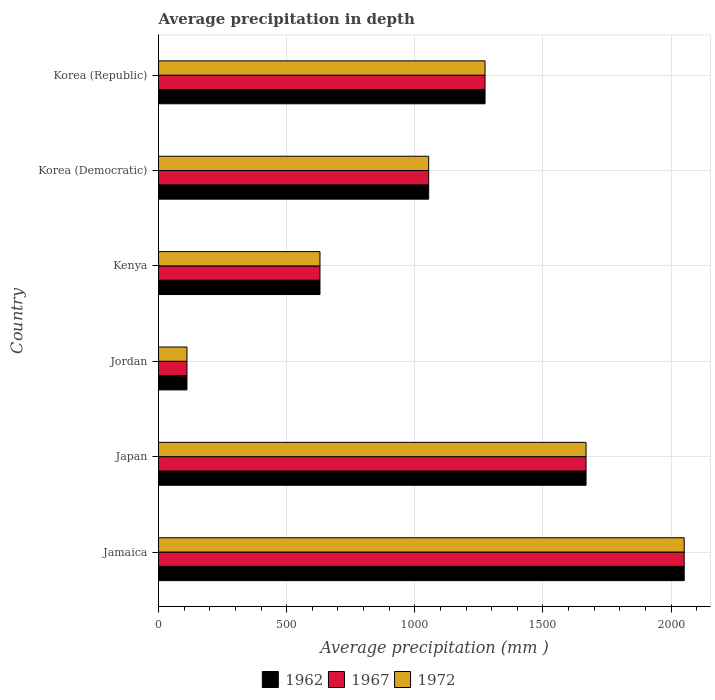How many different coloured bars are there?
Your answer should be very brief. 3. How many groups of bars are there?
Offer a very short reply. 6. How many bars are there on the 3rd tick from the top?
Make the answer very short. 3. What is the average precipitation in 1972 in Kenya?
Your answer should be compact. 630. Across all countries, what is the maximum average precipitation in 1967?
Provide a short and direct response. 2051. Across all countries, what is the minimum average precipitation in 1972?
Provide a short and direct response. 111. In which country was the average precipitation in 1962 maximum?
Provide a succinct answer. Jamaica. In which country was the average precipitation in 1962 minimum?
Your answer should be compact. Jordan. What is the total average precipitation in 1967 in the graph?
Ensure brevity in your answer.  6788. What is the difference between the average precipitation in 1967 in Jordan and that in Kenya?
Your answer should be compact. -519. What is the difference between the average precipitation in 1972 in Japan and the average precipitation in 1967 in Korea (Republic)?
Offer a very short reply. 394. What is the average average precipitation in 1962 per country?
Offer a terse response. 1131.33. What is the difference between the average precipitation in 1972 and average precipitation in 1967 in Kenya?
Your answer should be very brief. 0. What is the ratio of the average precipitation in 1972 in Japan to that in Kenya?
Make the answer very short. 2.65. Is the average precipitation in 1967 in Jamaica less than that in Jordan?
Your answer should be very brief. No. What is the difference between the highest and the second highest average precipitation in 1967?
Your answer should be very brief. 383. What is the difference between the highest and the lowest average precipitation in 1972?
Your answer should be compact. 1940. In how many countries, is the average precipitation in 1962 greater than the average average precipitation in 1962 taken over all countries?
Keep it short and to the point. 3. What does the 3rd bar from the bottom in Korea (Democratic) represents?
Your answer should be very brief. 1972. How many bars are there?
Make the answer very short. 18. What is the difference between two consecutive major ticks on the X-axis?
Keep it short and to the point. 500. Does the graph contain any zero values?
Offer a very short reply. No. How many legend labels are there?
Keep it short and to the point. 3. What is the title of the graph?
Your response must be concise. Average precipitation in depth. What is the label or title of the X-axis?
Give a very brief answer. Average precipitation (mm ). What is the Average precipitation (mm ) in 1962 in Jamaica?
Give a very brief answer. 2051. What is the Average precipitation (mm ) of 1967 in Jamaica?
Give a very brief answer. 2051. What is the Average precipitation (mm ) of 1972 in Jamaica?
Make the answer very short. 2051. What is the Average precipitation (mm ) in 1962 in Japan?
Your response must be concise. 1668. What is the Average precipitation (mm ) of 1967 in Japan?
Ensure brevity in your answer.  1668. What is the Average precipitation (mm ) in 1972 in Japan?
Keep it short and to the point. 1668. What is the Average precipitation (mm ) of 1962 in Jordan?
Your answer should be very brief. 111. What is the Average precipitation (mm ) of 1967 in Jordan?
Make the answer very short. 111. What is the Average precipitation (mm ) of 1972 in Jordan?
Offer a very short reply. 111. What is the Average precipitation (mm ) of 1962 in Kenya?
Make the answer very short. 630. What is the Average precipitation (mm ) of 1967 in Kenya?
Your answer should be compact. 630. What is the Average precipitation (mm ) of 1972 in Kenya?
Ensure brevity in your answer.  630. What is the Average precipitation (mm ) of 1962 in Korea (Democratic)?
Ensure brevity in your answer.  1054. What is the Average precipitation (mm ) of 1967 in Korea (Democratic)?
Give a very brief answer. 1054. What is the Average precipitation (mm ) of 1972 in Korea (Democratic)?
Make the answer very short. 1054. What is the Average precipitation (mm ) in 1962 in Korea (Republic)?
Your answer should be compact. 1274. What is the Average precipitation (mm ) of 1967 in Korea (Republic)?
Offer a very short reply. 1274. What is the Average precipitation (mm ) in 1972 in Korea (Republic)?
Make the answer very short. 1274. Across all countries, what is the maximum Average precipitation (mm ) in 1962?
Ensure brevity in your answer.  2051. Across all countries, what is the maximum Average precipitation (mm ) in 1967?
Ensure brevity in your answer.  2051. Across all countries, what is the maximum Average precipitation (mm ) in 1972?
Offer a very short reply. 2051. Across all countries, what is the minimum Average precipitation (mm ) of 1962?
Offer a terse response. 111. Across all countries, what is the minimum Average precipitation (mm ) in 1967?
Your answer should be compact. 111. Across all countries, what is the minimum Average precipitation (mm ) in 1972?
Offer a terse response. 111. What is the total Average precipitation (mm ) in 1962 in the graph?
Ensure brevity in your answer.  6788. What is the total Average precipitation (mm ) in 1967 in the graph?
Make the answer very short. 6788. What is the total Average precipitation (mm ) of 1972 in the graph?
Offer a terse response. 6788. What is the difference between the Average precipitation (mm ) in 1962 in Jamaica and that in Japan?
Offer a terse response. 383. What is the difference between the Average precipitation (mm ) in 1967 in Jamaica and that in Japan?
Provide a succinct answer. 383. What is the difference between the Average precipitation (mm ) of 1972 in Jamaica and that in Japan?
Make the answer very short. 383. What is the difference between the Average precipitation (mm ) of 1962 in Jamaica and that in Jordan?
Offer a terse response. 1940. What is the difference between the Average precipitation (mm ) of 1967 in Jamaica and that in Jordan?
Offer a terse response. 1940. What is the difference between the Average precipitation (mm ) of 1972 in Jamaica and that in Jordan?
Keep it short and to the point. 1940. What is the difference between the Average precipitation (mm ) in 1962 in Jamaica and that in Kenya?
Your answer should be compact. 1421. What is the difference between the Average precipitation (mm ) of 1967 in Jamaica and that in Kenya?
Provide a short and direct response. 1421. What is the difference between the Average precipitation (mm ) in 1972 in Jamaica and that in Kenya?
Your answer should be compact. 1421. What is the difference between the Average precipitation (mm ) in 1962 in Jamaica and that in Korea (Democratic)?
Your response must be concise. 997. What is the difference between the Average precipitation (mm ) in 1967 in Jamaica and that in Korea (Democratic)?
Keep it short and to the point. 997. What is the difference between the Average precipitation (mm ) of 1972 in Jamaica and that in Korea (Democratic)?
Your answer should be compact. 997. What is the difference between the Average precipitation (mm ) of 1962 in Jamaica and that in Korea (Republic)?
Provide a succinct answer. 777. What is the difference between the Average precipitation (mm ) in 1967 in Jamaica and that in Korea (Republic)?
Your answer should be compact. 777. What is the difference between the Average precipitation (mm ) in 1972 in Jamaica and that in Korea (Republic)?
Ensure brevity in your answer.  777. What is the difference between the Average precipitation (mm ) of 1962 in Japan and that in Jordan?
Offer a terse response. 1557. What is the difference between the Average precipitation (mm ) of 1967 in Japan and that in Jordan?
Provide a short and direct response. 1557. What is the difference between the Average precipitation (mm ) in 1972 in Japan and that in Jordan?
Your answer should be compact. 1557. What is the difference between the Average precipitation (mm ) in 1962 in Japan and that in Kenya?
Your response must be concise. 1038. What is the difference between the Average precipitation (mm ) of 1967 in Japan and that in Kenya?
Provide a succinct answer. 1038. What is the difference between the Average precipitation (mm ) in 1972 in Japan and that in Kenya?
Provide a succinct answer. 1038. What is the difference between the Average precipitation (mm ) in 1962 in Japan and that in Korea (Democratic)?
Ensure brevity in your answer.  614. What is the difference between the Average precipitation (mm ) in 1967 in Japan and that in Korea (Democratic)?
Keep it short and to the point. 614. What is the difference between the Average precipitation (mm ) of 1972 in Japan and that in Korea (Democratic)?
Your answer should be very brief. 614. What is the difference between the Average precipitation (mm ) of 1962 in Japan and that in Korea (Republic)?
Your answer should be compact. 394. What is the difference between the Average precipitation (mm ) in 1967 in Japan and that in Korea (Republic)?
Keep it short and to the point. 394. What is the difference between the Average precipitation (mm ) in 1972 in Japan and that in Korea (Republic)?
Offer a terse response. 394. What is the difference between the Average precipitation (mm ) of 1962 in Jordan and that in Kenya?
Provide a succinct answer. -519. What is the difference between the Average precipitation (mm ) of 1967 in Jordan and that in Kenya?
Your answer should be compact. -519. What is the difference between the Average precipitation (mm ) in 1972 in Jordan and that in Kenya?
Make the answer very short. -519. What is the difference between the Average precipitation (mm ) of 1962 in Jordan and that in Korea (Democratic)?
Keep it short and to the point. -943. What is the difference between the Average precipitation (mm ) of 1967 in Jordan and that in Korea (Democratic)?
Your response must be concise. -943. What is the difference between the Average precipitation (mm ) in 1972 in Jordan and that in Korea (Democratic)?
Keep it short and to the point. -943. What is the difference between the Average precipitation (mm ) of 1962 in Jordan and that in Korea (Republic)?
Provide a succinct answer. -1163. What is the difference between the Average precipitation (mm ) in 1967 in Jordan and that in Korea (Republic)?
Offer a terse response. -1163. What is the difference between the Average precipitation (mm ) in 1972 in Jordan and that in Korea (Republic)?
Make the answer very short. -1163. What is the difference between the Average precipitation (mm ) of 1962 in Kenya and that in Korea (Democratic)?
Your answer should be very brief. -424. What is the difference between the Average precipitation (mm ) in 1967 in Kenya and that in Korea (Democratic)?
Make the answer very short. -424. What is the difference between the Average precipitation (mm ) in 1972 in Kenya and that in Korea (Democratic)?
Keep it short and to the point. -424. What is the difference between the Average precipitation (mm ) of 1962 in Kenya and that in Korea (Republic)?
Offer a very short reply. -644. What is the difference between the Average precipitation (mm ) of 1967 in Kenya and that in Korea (Republic)?
Ensure brevity in your answer.  -644. What is the difference between the Average precipitation (mm ) of 1972 in Kenya and that in Korea (Republic)?
Provide a short and direct response. -644. What is the difference between the Average precipitation (mm ) in 1962 in Korea (Democratic) and that in Korea (Republic)?
Keep it short and to the point. -220. What is the difference between the Average precipitation (mm ) in 1967 in Korea (Democratic) and that in Korea (Republic)?
Offer a terse response. -220. What is the difference between the Average precipitation (mm ) in 1972 in Korea (Democratic) and that in Korea (Republic)?
Ensure brevity in your answer.  -220. What is the difference between the Average precipitation (mm ) of 1962 in Jamaica and the Average precipitation (mm ) of 1967 in Japan?
Provide a short and direct response. 383. What is the difference between the Average precipitation (mm ) of 1962 in Jamaica and the Average precipitation (mm ) of 1972 in Japan?
Offer a very short reply. 383. What is the difference between the Average precipitation (mm ) in 1967 in Jamaica and the Average precipitation (mm ) in 1972 in Japan?
Your answer should be compact. 383. What is the difference between the Average precipitation (mm ) of 1962 in Jamaica and the Average precipitation (mm ) of 1967 in Jordan?
Ensure brevity in your answer.  1940. What is the difference between the Average precipitation (mm ) of 1962 in Jamaica and the Average precipitation (mm ) of 1972 in Jordan?
Ensure brevity in your answer.  1940. What is the difference between the Average precipitation (mm ) in 1967 in Jamaica and the Average precipitation (mm ) in 1972 in Jordan?
Your response must be concise. 1940. What is the difference between the Average precipitation (mm ) in 1962 in Jamaica and the Average precipitation (mm ) in 1967 in Kenya?
Provide a succinct answer. 1421. What is the difference between the Average precipitation (mm ) in 1962 in Jamaica and the Average precipitation (mm ) in 1972 in Kenya?
Provide a succinct answer. 1421. What is the difference between the Average precipitation (mm ) of 1967 in Jamaica and the Average precipitation (mm ) of 1972 in Kenya?
Offer a very short reply. 1421. What is the difference between the Average precipitation (mm ) in 1962 in Jamaica and the Average precipitation (mm ) in 1967 in Korea (Democratic)?
Provide a succinct answer. 997. What is the difference between the Average precipitation (mm ) in 1962 in Jamaica and the Average precipitation (mm ) in 1972 in Korea (Democratic)?
Make the answer very short. 997. What is the difference between the Average precipitation (mm ) in 1967 in Jamaica and the Average precipitation (mm ) in 1972 in Korea (Democratic)?
Offer a very short reply. 997. What is the difference between the Average precipitation (mm ) of 1962 in Jamaica and the Average precipitation (mm ) of 1967 in Korea (Republic)?
Offer a very short reply. 777. What is the difference between the Average precipitation (mm ) in 1962 in Jamaica and the Average precipitation (mm ) in 1972 in Korea (Republic)?
Your answer should be very brief. 777. What is the difference between the Average precipitation (mm ) in 1967 in Jamaica and the Average precipitation (mm ) in 1972 in Korea (Republic)?
Make the answer very short. 777. What is the difference between the Average precipitation (mm ) of 1962 in Japan and the Average precipitation (mm ) of 1967 in Jordan?
Provide a succinct answer. 1557. What is the difference between the Average precipitation (mm ) in 1962 in Japan and the Average precipitation (mm ) in 1972 in Jordan?
Keep it short and to the point. 1557. What is the difference between the Average precipitation (mm ) of 1967 in Japan and the Average precipitation (mm ) of 1972 in Jordan?
Your response must be concise. 1557. What is the difference between the Average precipitation (mm ) in 1962 in Japan and the Average precipitation (mm ) in 1967 in Kenya?
Provide a short and direct response. 1038. What is the difference between the Average precipitation (mm ) of 1962 in Japan and the Average precipitation (mm ) of 1972 in Kenya?
Your answer should be compact. 1038. What is the difference between the Average precipitation (mm ) of 1967 in Japan and the Average precipitation (mm ) of 1972 in Kenya?
Offer a very short reply. 1038. What is the difference between the Average precipitation (mm ) of 1962 in Japan and the Average precipitation (mm ) of 1967 in Korea (Democratic)?
Make the answer very short. 614. What is the difference between the Average precipitation (mm ) in 1962 in Japan and the Average precipitation (mm ) in 1972 in Korea (Democratic)?
Ensure brevity in your answer.  614. What is the difference between the Average precipitation (mm ) in 1967 in Japan and the Average precipitation (mm ) in 1972 in Korea (Democratic)?
Offer a very short reply. 614. What is the difference between the Average precipitation (mm ) in 1962 in Japan and the Average precipitation (mm ) in 1967 in Korea (Republic)?
Make the answer very short. 394. What is the difference between the Average precipitation (mm ) of 1962 in Japan and the Average precipitation (mm ) of 1972 in Korea (Republic)?
Provide a short and direct response. 394. What is the difference between the Average precipitation (mm ) of 1967 in Japan and the Average precipitation (mm ) of 1972 in Korea (Republic)?
Make the answer very short. 394. What is the difference between the Average precipitation (mm ) of 1962 in Jordan and the Average precipitation (mm ) of 1967 in Kenya?
Offer a very short reply. -519. What is the difference between the Average precipitation (mm ) in 1962 in Jordan and the Average precipitation (mm ) in 1972 in Kenya?
Offer a very short reply. -519. What is the difference between the Average precipitation (mm ) of 1967 in Jordan and the Average precipitation (mm ) of 1972 in Kenya?
Provide a short and direct response. -519. What is the difference between the Average precipitation (mm ) of 1962 in Jordan and the Average precipitation (mm ) of 1967 in Korea (Democratic)?
Provide a short and direct response. -943. What is the difference between the Average precipitation (mm ) in 1962 in Jordan and the Average precipitation (mm ) in 1972 in Korea (Democratic)?
Provide a succinct answer. -943. What is the difference between the Average precipitation (mm ) of 1967 in Jordan and the Average precipitation (mm ) of 1972 in Korea (Democratic)?
Your response must be concise. -943. What is the difference between the Average precipitation (mm ) in 1962 in Jordan and the Average precipitation (mm ) in 1967 in Korea (Republic)?
Your answer should be very brief. -1163. What is the difference between the Average precipitation (mm ) in 1962 in Jordan and the Average precipitation (mm ) in 1972 in Korea (Republic)?
Your answer should be compact. -1163. What is the difference between the Average precipitation (mm ) of 1967 in Jordan and the Average precipitation (mm ) of 1972 in Korea (Republic)?
Offer a very short reply. -1163. What is the difference between the Average precipitation (mm ) in 1962 in Kenya and the Average precipitation (mm ) in 1967 in Korea (Democratic)?
Your answer should be compact. -424. What is the difference between the Average precipitation (mm ) of 1962 in Kenya and the Average precipitation (mm ) of 1972 in Korea (Democratic)?
Keep it short and to the point. -424. What is the difference between the Average precipitation (mm ) of 1967 in Kenya and the Average precipitation (mm ) of 1972 in Korea (Democratic)?
Your response must be concise. -424. What is the difference between the Average precipitation (mm ) in 1962 in Kenya and the Average precipitation (mm ) in 1967 in Korea (Republic)?
Keep it short and to the point. -644. What is the difference between the Average precipitation (mm ) of 1962 in Kenya and the Average precipitation (mm ) of 1972 in Korea (Republic)?
Make the answer very short. -644. What is the difference between the Average precipitation (mm ) of 1967 in Kenya and the Average precipitation (mm ) of 1972 in Korea (Republic)?
Keep it short and to the point. -644. What is the difference between the Average precipitation (mm ) of 1962 in Korea (Democratic) and the Average precipitation (mm ) of 1967 in Korea (Republic)?
Your answer should be very brief. -220. What is the difference between the Average precipitation (mm ) of 1962 in Korea (Democratic) and the Average precipitation (mm ) of 1972 in Korea (Republic)?
Provide a succinct answer. -220. What is the difference between the Average precipitation (mm ) in 1967 in Korea (Democratic) and the Average precipitation (mm ) in 1972 in Korea (Republic)?
Make the answer very short. -220. What is the average Average precipitation (mm ) of 1962 per country?
Give a very brief answer. 1131.33. What is the average Average precipitation (mm ) of 1967 per country?
Keep it short and to the point. 1131.33. What is the average Average precipitation (mm ) of 1972 per country?
Provide a short and direct response. 1131.33. What is the difference between the Average precipitation (mm ) of 1962 and Average precipitation (mm ) of 1972 in Jamaica?
Ensure brevity in your answer.  0. What is the difference between the Average precipitation (mm ) in 1967 and Average precipitation (mm ) in 1972 in Jordan?
Provide a short and direct response. 0. What is the difference between the Average precipitation (mm ) in 1962 and Average precipitation (mm ) in 1967 in Kenya?
Give a very brief answer. 0. What is the difference between the Average precipitation (mm ) of 1962 and Average precipitation (mm ) of 1972 in Kenya?
Your answer should be very brief. 0. What is the difference between the Average precipitation (mm ) in 1967 and Average precipitation (mm ) in 1972 in Kenya?
Make the answer very short. 0. What is the difference between the Average precipitation (mm ) in 1967 and Average precipitation (mm ) in 1972 in Korea (Republic)?
Your answer should be very brief. 0. What is the ratio of the Average precipitation (mm ) of 1962 in Jamaica to that in Japan?
Provide a succinct answer. 1.23. What is the ratio of the Average precipitation (mm ) in 1967 in Jamaica to that in Japan?
Your response must be concise. 1.23. What is the ratio of the Average precipitation (mm ) in 1972 in Jamaica to that in Japan?
Your answer should be very brief. 1.23. What is the ratio of the Average precipitation (mm ) in 1962 in Jamaica to that in Jordan?
Give a very brief answer. 18.48. What is the ratio of the Average precipitation (mm ) in 1967 in Jamaica to that in Jordan?
Give a very brief answer. 18.48. What is the ratio of the Average precipitation (mm ) in 1972 in Jamaica to that in Jordan?
Offer a terse response. 18.48. What is the ratio of the Average precipitation (mm ) of 1962 in Jamaica to that in Kenya?
Ensure brevity in your answer.  3.26. What is the ratio of the Average precipitation (mm ) in 1967 in Jamaica to that in Kenya?
Offer a terse response. 3.26. What is the ratio of the Average precipitation (mm ) of 1972 in Jamaica to that in Kenya?
Ensure brevity in your answer.  3.26. What is the ratio of the Average precipitation (mm ) of 1962 in Jamaica to that in Korea (Democratic)?
Keep it short and to the point. 1.95. What is the ratio of the Average precipitation (mm ) in 1967 in Jamaica to that in Korea (Democratic)?
Provide a short and direct response. 1.95. What is the ratio of the Average precipitation (mm ) of 1972 in Jamaica to that in Korea (Democratic)?
Your answer should be compact. 1.95. What is the ratio of the Average precipitation (mm ) in 1962 in Jamaica to that in Korea (Republic)?
Provide a succinct answer. 1.61. What is the ratio of the Average precipitation (mm ) in 1967 in Jamaica to that in Korea (Republic)?
Your response must be concise. 1.61. What is the ratio of the Average precipitation (mm ) in 1972 in Jamaica to that in Korea (Republic)?
Keep it short and to the point. 1.61. What is the ratio of the Average precipitation (mm ) in 1962 in Japan to that in Jordan?
Keep it short and to the point. 15.03. What is the ratio of the Average precipitation (mm ) in 1967 in Japan to that in Jordan?
Offer a terse response. 15.03. What is the ratio of the Average precipitation (mm ) of 1972 in Japan to that in Jordan?
Your answer should be compact. 15.03. What is the ratio of the Average precipitation (mm ) in 1962 in Japan to that in Kenya?
Ensure brevity in your answer.  2.65. What is the ratio of the Average precipitation (mm ) in 1967 in Japan to that in Kenya?
Keep it short and to the point. 2.65. What is the ratio of the Average precipitation (mm ) of 1972 in Japan to that in Kenya?
Provide a succinct answer. 2.65. What is the ratio of the Average precipitation (mm ) in 1962 in Japan to that in Korea (Democratic)?
Offer a very short reply. 1.58. What is the ratio of the Average precipitation (mm ) of 1967 in Japan to that in Korea (Democratic)?
Offer a terse response. 1.58. What is the ratio of the Average precipitation (mm ) in 1972 in Japan to that in Korea (Democratic)?
Your answer should be compact. 1.58. What is the ratio of the Average precipitation (mm ) in 1962 in Japan to that in Korea (Republic)?
Offer a very short reply. 1.31. What is the ratio of the Average precipitation (mm ) of 1967 in Japan to that in Korea (Republic)?
Provide a short and direct response. 1.31. What is the ratio of the Average precipitation (mm ) of 1972 in Japan to that in Korea (Republic)?
Offer a terse response. 1.31. What is the ratio of the Average precipitation (mm ) in 1962 in Jordan to that in Kenya?
Make the answer very short. 0.18. What is the ratio of the Average precipitation (mm ) of 1967 in Jordan to that in Kenya?
Your answer should be compact. 0.18. What is the ratio of the Average precipitation (mm ) in 1972 in Jordan to that in Kenya?
Offer a very short reply. 0.18. What is the ratio of the Average precipitation (mm ) of 1962 in Jordan to that in Korea (Democratic)?
Provide a short and direct response. 0.11. What is the ratio of the Average precipitation (mm ) in 1967 in Jordan to that in Korea (Democratic)?
Your response must be concise. 0.11. What is the ratio of the Average precipitation (mm ) of 1972 in Jordan to that in Korea (Democratic)?
Your answer should be very brief. 0.11. What is the ratio of the Average precipitation (mm ) of 1962 in Jordan to that in Korea (Republic)?
Provide a succinct answer. 0.09. What is the ratio of the Average precipitation (mm ) in 1967 in Jordan to that in Korea (Republic)?
Provide a succinct answer. 0.09. What is the ratio of the Average precipitation (mm ) of 1972 in Jordan to that in Korea (Republic)?
Make the answer very short. 0.09. What is the ratio of the Average precipitation (mm ) in 1962 in Kenya to that in Korea (Democratic)?
Ensure brevity in your answer.  0.6. What is the ratio of the Average precipitation (mm ) of 1967 in Kenya to that in Korea (Democratic)?
Ensure brevity in your answer.  0.6. What is the ratio of the Average precipitation (mm ) of 1972 in Kenya to that in Korea (Democratic)?
Offer a terse response. 0.6. What is the ratio of the Average precipitation (mm ) of 1962 in Kenya to that in Korea (Republic)?
Offer a very short reply. 0.49. What is the ratio of the Average precipitation (mm ) of 1967 in Kenya to that in Korea (Republic)?
Your response must be concise. 0.49. What is the ratio of the Average precipitation (mm ) of 1972 in Kenya to that in Korea (Republic)?
Offer a very short reply. 0.49. What is the ratio of the Average precipitation (mm ) of 1962 in Korea (Democratic) to that in Korea (Republic)?
Keep it short and to the point. 0.83. What is the ratio of the Average precipitation (mm ) of 1967 in Korea (Democratic) to that in Korea (Republic)?
Ensure brevity in your answer.  0.83. What is the ratio of the Average precipitation (mm ) of 1972 in Korea (Democratic) to that in Korea (Republic)?
Keep it short and to the point. 0.83. What is the difference between the highest and the second highest Average precipitation (mm ) of 1962?
Offer a very short reply. 383. What is the difference between the highest and the second highest Average precipitation (mm ) of 1967?
Your answer should be very brief. 383. What is the difference between the highest and the second highest Average precipitation (mm ) of 1972?
Offer a terse response. 383. What is the difference between the highest and the lowest Average precipitation (mm ) of 1962?
Provide a succinct answer. 1940. What is the difference between the highest and the lowest Average precipitation (mm ) of 1967?
Provide a succinct answer. 1940. What is the difference between the highest and the lowest Average precipitation (mm ) of 1972?
Provide a succinct answer. 1940. 